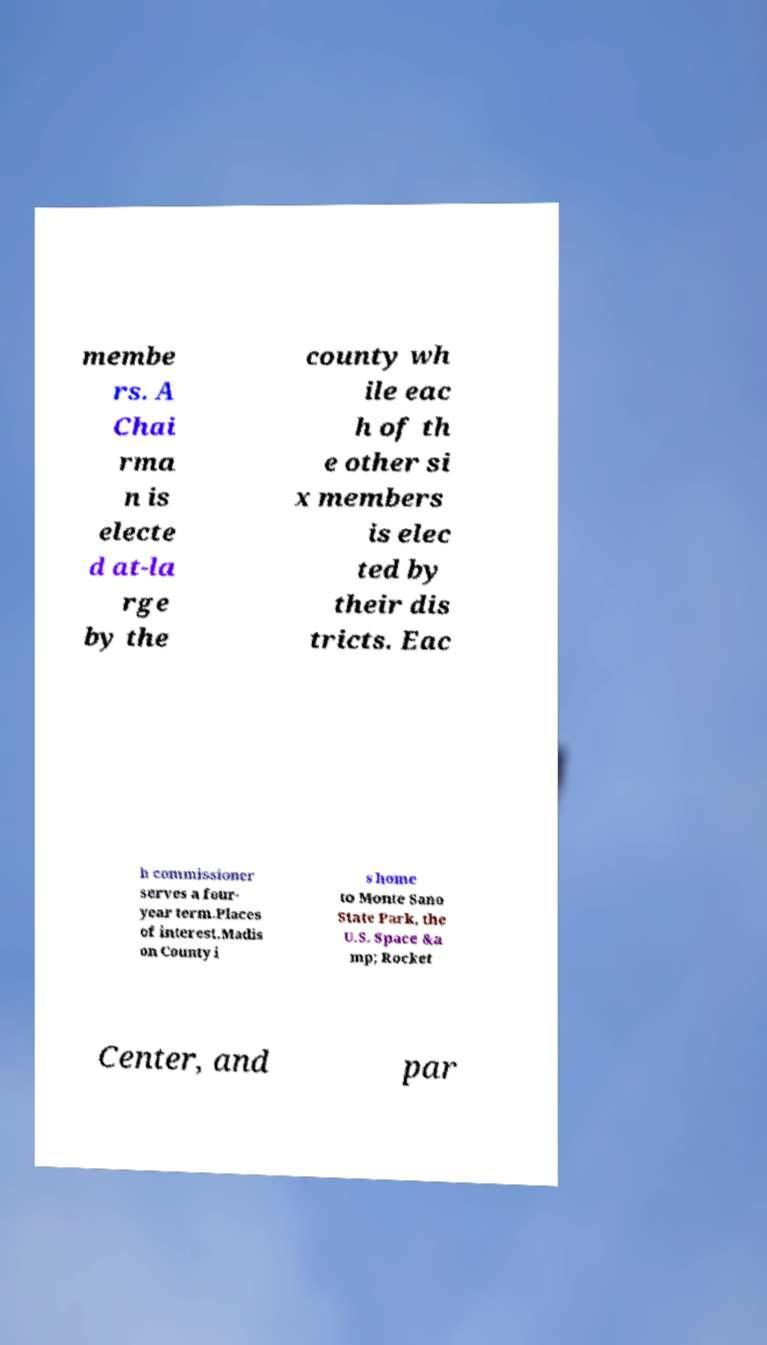Please read and relay the text visible in this image. What does it say? membe rs. A Chai rma n is electe d at-la rge by the county wh ile eac h of th e other si x members is elec ted by their dis tricts. Eac h commissioner serves a four- year term.Places of interest.Madis on County i s home to Monte Sano State Park, the U.S. Space &a mp; Rocket Center, and par 